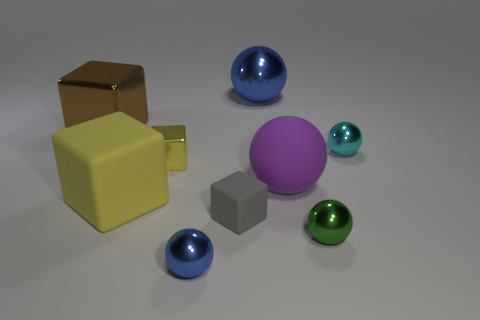Subtract all cyan spheres. How many spheres are left? 4 Subtract all green shiny spheres. How many spheres are left? 4 Subtract all yellow balls. Subtract all brown cylinders. How many balls are left? 5 Subtract all green balls. How many yellow cubes are left? 2 Add 4 tiny cyan metal things. How many tiny cyan metal things are left? 5 Add 6 big yellow things. How many big yellow things exist? 7 Subtract 1 cyan spheres. How many objects are left? 8 Subtract all blocks. How many objects are left? 5 Subtract 4 spheres. How many spheres are left? 1 Subtract all small green metallic balls. Subtract all green spheres. How many objects are left? 7 